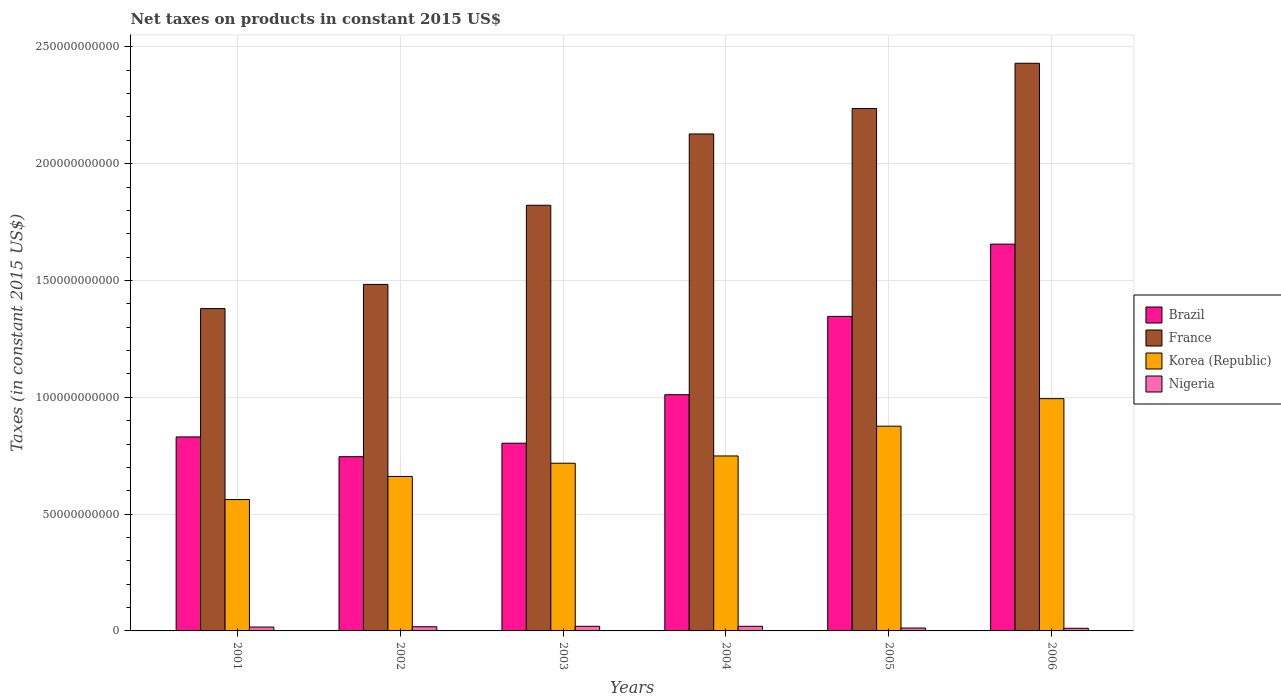How many groups of bars are there?
Provide a short and direct response. 6. Are the number of bars per tick equal to the number of legend labels?
Your response must be concise. Yes. Are the number of bars on each tick of the X-axis equal?
Your answer should be compact. Yes. How many bars are there on the 4th tick from the left?
Your answer should be compact. 4. How many bars are there on the 4th tick from the right?
Your answer should be compact. 4. What is the label of the 6th group of bars from the left?
Give a very brief answer. 2006. In how many cases, is the number of bars for a given year not equal to the number of legend labels?
Provide a succinct answer. 0. What is the net taxes on products in France in 2005?
Offer a very short reply. 2.24e+11. Across all years, what is the maximum net taxes on products in France?
Offer a terse response. 2.43e+11. Across all years, what is the minimum net taxes on products in France?
Keep it short and to the point. 1.38e+11. In which year was the net taxes on products in Korea (Republic) minimum?
Make the answer very short. 2001. What is the total net taxes on products in Nigeria in the graph?
Provide a succinct answer. 9.77e+09. What is the difference between the net taxes on products in Nigeria in 2002 and that in 2003?
Your answer should be compact. -1.88e+08. What is the difference between the net taxes on products in Nigeria in 2005 and the net taxes on products in Brazil in 2003?
Provide a succinct answer. -7.91e+1. What is the average net taxes on products in Korea (Republic) per year?
Make the answer very short. 7.60e+1. In the year 2005, what is the difference between the net taxes on products in Brazil and net taxes on products in Korea (Republic)?
Your answer should be very brief. 4.70e+1. What is the ratio of the net taxes on products in Brazil in 2002 to that in 2004?
Give a very brief answer. 0.74. Is the difference between the net taxes on products in Brazil in 2002 and 2005 greater than the difference between the net taxes on products in Korea (Republic) in 2002 and 2005?
Make the answer very short. No. What is the difference between the highest and the second highest net taxes on products in Brazil?
Ensure brevity in your answer.  3.09e+1. What is the difference between the highest and the lowest net taxes on products in Brazil?
Provide a succinct answer. 9.10e+1. What does the 2nd bar from the left in 2005 represents?
Give a very brief answer. France. What does the 2nd bar from the right in 2004 represents?
Your answer should be very brief. Korea (Republic). Is it the case that in every year, the sum of the net taxes on products in Nigeria and net taxes on products in Korea (Republic) is greater than the net taxes on products in France?
Your answer should be compact. No. Are all the bars in the graph horizontal?
Give a very brief answer. No. Does the graph contain any zero values?
Provide a short and direct response. No. Does the graph contain grids?
Give a very brief answer. Yes. Where does the legend appear in the graph?
Ensure brevity in your answer.  Center right. How many legend labels are there?
Keep it short and to the point. 4. What is the title of the graph?
Give a very brief answer. Net taxes on products in constant 2015 US$. What is the label or title of the Y-axis?
Your answer should be compact. Taxes (in constant 2015 US$). What is the Taxes (in constant 2015 US$) in Brazil in 2001?
Your answer should be very brief. 8.30e+1. What is the Taxes (in constant 2015 US$) in France in 2001?
Your answer should be very brief. 1.38e+11. What is the Taxes (in constant 2015 US$) in Korea (Republic) in 2001?
Ensure brevity in your answer.  5.62e+1. What is the Taxes (in constant 2015 US$) in Nigeria in 2001?
Ensure brevity in your answer.  1.66e+09. What is the Taxes (in constant 2015 US$) in Brazil in 2002?
Provide a succinct answer. 7.46e+1. What is the Taxes (in constant 2015 US$) in France in 2002?
Your answer should be very brief. 1.48e+11. What is the Taxes (in constant 2015 US$) of Korea (Republic) in 2002?
Offer a terse response. 6.61e+1. What is the Taxes (in constant 2015 US$) of Nigeria in 2002?
Keep it short and to the point. 1.79e+09. What is the Taxes (in constant 2015 US$) of Brazil in 2003?
Provide a succinct answer. 8.03e+1. What is the Taxes (in constant 2015 US$) of France in 2003?
Offer a very short reply. 1.82e+11. What is the Taxes (in constant 2015 US$) in Korea (Republic) in 2003?
Give a very brief answer. 7.18e+1. What is the Taxes (in constant 2015 US$) of Nigeria in 2003?
Give a very brief answer. 1.98e+09. What is the Taxes (in constant 2015 US$) of Brazil in 2004?
Provide a succinct answer. 1.01e+11. What is the Taxes (in constant 2015 US$) of France in 2004?
Keep it short and to the point. 2.13e+11. What is the Taxes (in constant 2015 US$) of Korea (Republic) in 2004?
Make the answer very short. 7.49e+1. What is the Taxes (in constant 2015 US$) in Nigeria in 2004?
Ensure brevity in your answer.  1.98e+09. What is the Taxes (in constant 2015 US$) of Brazil in 2005?
Provide a succinct answer. 1.35e+11. What is the Taxes (in constant 2015 US$) of France in 2005?
Offer a terse response. 2.24e+11. What is the Taxes (in constant 2015 US$) of Korea (Republic) in 2005?
Provide a succinct answer. 8.76e+1. What is the Taxes (in constant 2015 US$) of Nigeria in 2005?
Offer a terse response. 1.24e+09. What is the Taxes (in constant 2015 US$) of Brazil in 2006?
Keep it short and to the point. 1.66e+11. What is the Taxes (in constant 2015 US$) in France in 2006?
Ensure brevity in your answer.  2.43e+11. What is the Taxes (in constant 2015 US$) of Korea (Republic) in 2006?
Provide a short and direct response. 9.94e+1. What is the Taxes (in constant 2015 US$) in Nigeria in 2006?
Offer a very short reply. 1.13e+09. Across all years, what is the maximum Taxes (in constant 2015 US$) of Brazil?
Keep it short and to the point. 1.66e+11. Across all years, what is the maximum Taxes (in constant 2015 US$) in France?
Ensure brevity in your answer.  2.43e+11. Across all years, what is the maximum Taxes (in constant 2015 US$) in Korea (Republic)?
Make the answer very short. 9.94e+1. Across all years, what is the maximum Taxes (in constant 2015 US$) in Nigeria?
Keep it short and to the point. 1.98e+09. Across all years, what is the minimum Taxes (in constant 2015 US$) of Brazil?
Give a very brief answer. 7.46e+1. Across all years, what is the minimum Taxes (in constant 2015 US$) of France?
Make the answer very short. 1.38e+11. Across all years, what is the minimum Taxes (in constant 2015 US$) of Korea (Republic)?
Your answer should be very brief. 5.62e+1. Across all years, what is the minimum Taxes (in constant 2015 US$) of Nigeria?
Ensure brevity in your answer.  1.13e+09. What is the total Taxes (in constant 2015 US$) in Brazil in the graph?
Make the answer very short. 6.39e+11. What is the total Taxes (in constant 2015 US$) in France in the graph?
Provide a short and direct response. 1.15e+12. What is the total Taxes (in constant 2015 US$) in Korea (Republic) in the graph?
Provide a short and direct response. 4.56e+11. What is the total Taxes (in constant 2015 US$) of Nigeria in the graph?
Offer a very short reply. 9.77e+09. What is the difference between the Taxes (in constant 2015 US$) in Brazil in 2001 and that in 2002?
Your answer should be compact. 8.47e+09. What is the difference between the Taxes (in constant 2015 US$) in France in 2001 and that in 2002?
Ensure brevity in your answer.  -1.04e+1. What is the difference between the Taxes (in constant 2015 US$) of Korea (Republic) in 2001 and that in 2002?
Your response must be concise. -9.88e+09. What is the difference between the Taxes (in constant 2015 US$) of Nigeria in 2001 and that in 2002?
Your answer should be very brief. -1.32e+08. What is the difference between the Taxes (in constant 2015 US$) of Brazil in 2001 and that in 2003?
Make the answer very short. 2.69e+09. What is the difference between the Taxes (in constant 2015 US$) in France in 2001 and that in 2003?
Make the answer very short. -4.42e+1. What is the difference between the Taxes (in constant 2015 US$) of Korea (Republic) in 2001 and that in 2003?
Your response must be concise. -1.55e+1. What is the difference between the Taxes (in constant 2015 US$) of Nigeria in 2001 and that in 2003?
Your response must be concise. -3.20e+08. What is the difference between the Taxes (in constant 2015 US$) in Brazil in 2001 and that in 2004?
Provide a succinct answer. -1.81e+1. What is the difference between the Taxes (in constant 2015 US$) in France in 2001 and that in 2004?
Give a very brief answer. -7.48e+1. What is the difference between the Taxes (in constant 2015 US$) of Korea (Republic) in 2001 and that in 2004?
Keep it short and to the point. -1.87e+1. What is the difference between the Taxes (in constant 2015 US$) in Nigeria in 2001 and that in 2004?
Offer a terse response. -3.17e+08. What is the difference between the Taxes (in constant 2015 US$) of Brazil in 2001 and that in 2005?
Make the answer very short. -5.16e+1. What is the difference between the Taxes (in constant 2015 US$) in France in 2001 and that in 2005?
Make the answer very short. -8.57e+1. What is the difference between the Taxes (in constant 2015 US$) of Korea (Republic) in 2001 and that in 2005?
Offer a terse response. -3.14e+1. What is the difference between the Taxes (in constant 2015 US$) of Nigeria in 2001 and that in 2005?
Offer a terse response. 4.16e+08. What is the difference between the Taxes (in constant 2015 US$) in Brazil in 2001 and that in 2006?
Offer a terse response. -8.25e+1. What is the difference between the Taxes (in constant 2015 US$) of France in 2001 and that in 2006?
Offer a very short reply. -1.05e+11. What is the difference between the Taxes (in constant 2015 US$) of Korea (Republic) in 2001 and that in 2006?
Provide a short and direct response. -4.32e+1. What is the difference between the Taxes (in constant 2015 US$) of Nigeria in 2001 and that in 2006?
Make the answer very short. 5.31e+08. What is the difference between the Taxes (in constant 2015 US$) of Brazil in 2002 and that in 2003?
Offer a terse response. -5.77e+09. What is the difference between the Taxes (in constant 2015 US$) of France in 2002 and that in 2003?
Your answer should be very brief. -3.39e+1. What is the difference between the Taxes (in constant 2015 US$) of Korea (Republic) in 2002 and that in 2003?
Provide a succinct answer. -5.66e+09. What is the difference between the Taxes (in constant 2015 US$) of Nigeria in 2002 and that in 2003?
Offer a terse response. -1.88e+08. What is the difference between the Taxes (in constant 2015 US$) of Brazil in 2002 and that in 2004?
Your response must be concise. -2.65e+1. What is the difference between the Taxes (in constant 2015 US$) of France in 2002 and that in 2004?
Ensure brevity in your answer.  -6.44e+1. What is the difference between the Taxes (in constant 2015 US$) in Korea (Republic) in 2002 and that in 2004?
Provide a succinct answer. -8.77e+09. What is the difference between the Taxes (in constant 2015 US$) of Nigeria in 2002 and that in 2004?
Provide a short and direct response. -1.86e+08. What is the difference between the Taxes (in constant 2015 US$) in Brazil in 2002 and that in 2005?
Provide a short and direct response. -6.01e+1. What is the difference between the Taxes (in constant 2015 US$) of France in 2002 and that in 2005?
Give a very brief answer. -7.53e+1. What is the difference between the Taxes (in constant 2015 US$) of Korea (Republic) in 2002 and that in 2005?
Your answer should be very brief. -2.15e+1. What is the difference between the Taxes (in constant 2015 US$) in Nigeria in 2002 and that in 2005?
Your response must be concise. 5.48e+08. What is the difference between the Taxes (in constant 2015 US$) of Brazil in 2002 and that in 2006?
Provide a succinct answer. -9.10e+1. What is the difference between the Taxes (in constant 2015 US$) of France in 2002 and that in 2006?
Your answer should be very brief. -9.47e+1. What is the difference between the Taxes (in constant 2015 US$) of Korea (Republic) in 2002 and that in 2006?
Your response must be concise. -3.33e+1. What is the difference between the Taxes (in constant 2015 US$) of Nigeria in 2002 and that in 2006?
Make the answer very short. 6.63e+08. What is the difference between the Taxes (in constant 2015 US$) in Brazil in 2003 and that in 2004?
Give a very brief answer. -2.08e+1. What is the difference between the Taxes (in constant 2015 US$) of France in 2003 and that in 2004?
Make the answer very short. -3.05e+1. What is the difference between the Taxes (in constant 2015 US$) in Korea (Republic) in 2003 and that in 2004?
Provide a short and direct response. -3.11e+09. What is the difference between the Taxes (in constant 2015 US$) of Nigeria in 2003 and that in 2004?
Your answer should be very brief. 2.49e+06. What is the difference between the Taxes (in constant 2015 US$) of Brazil in 2003 and that in 2005?
Make the answer very short. -5.43e+1. What is the difference between the Taxes (in constant 2015 US$) of France in 2003 and that in 2005?
Ensure brevity in your answer.  -4.14e+1. What is the difference between the Taxes (in constant 2015 US$) in Korea (Republic) in 2003 and that in 2005?
Keep it short and to the point. -1.59e+1. What is the difference between the Taxes (in constant 2015 US$) of Nigeria in 2003 and that in 2005?
Give a very brief answer. 7.36e+08. What is the difference between the Taxes (in constant 2015 US$) of Brazil in 2003 and that in 2006?
Your answer should be very brief. -8.52e+1. What is the difference between the Taxes (in constant 2015 US$) in France in 2003 and that in 2006?
Offer a very short reply. -6.08e+1. What is the difference between the Taxes (in constant 2015 US$) of Korea (Republic) in 2003 and that in 2006?
Offer a very short reply. -2.76e+1. What is the difference between the Taxes (in constant 2015 US$) in Nigeria in 2003 and that in 2006?
Your response must be concise. 8.51e+08. What is the difference between the Taxes (in constant 2015 US$) in Brazil in 2004 and that in 2005?
Keep it short and to the point. -3.35e+1. What is the difference between the Taxes (in constant 2015 US$) in France in 2004 and that in 2005?
Provide a succinct answer. -1.09e+1. What is the difference between the Taxes (in constant 2015 US$) of Korea (Republic) in 2004 and that in 2005?
Your response must be concise. -1.27e+1. What is the difference between the Taxes (in constant 2015 US$) in Nigeria in 2004 and that in 2005?
Keep it short and to the point. 7.33e+08. What is the difference between the Taxes (in constant 2015 US$) in Brazil in 2004 and that in 2006?
Your response must be concise. -6.45e+1. What is the difference between the Taxes (in constant 2015 US$) in France in 2004 and that in 2006?
Offer a very short reply. -3.03e+1. What is the difference between the Taxes (in constant 2015 US$) in Korea (Republic) in 2004 and that in 2006?
Provide a succinct answer. -2.45e+1. What is the difference between the Taxes (in constant 2015 US$) in Nigeria in 2004 and that in 2006?
Your answer should be compact. 8.49e+08. What is the difference between the Taxes (in constant 2015 US$) in Brazil in 2005 and that in 2006?
Provide a succinct answer. -3.09e+1. What is the difference between the Taxes (in constant 2015 US$) in France in 2005 and that in 2006?
Provide a succinct answer. -1.94e+1. What is the difference between the Taxes (in constant 2015 US$) in Korea (Republic) in 2005 and that in 2006?
Your answer should be very brief. -1.18e+1. What is the difference between the Taxes (in constant 2015 US$) of Nigeria in 2005 and that in 2006?
Your answer should be compact. 1.15e+08. What is the difference between the Taxes (in constant 2015 US$) in Brazil in 2001 and the Taxes (in constant 2015 US$) in France in 2002?
Provide a succinct answer. -6.53e+1. What is the difference between the Taxes (in constant 2015 US$) in Brazil in 2001 and the Taxes (in constant 2015 US$) in Korea (Republic) in 2002?
Your answer should be very brief. 1.69e+1. What is the difference between the Taxes (in constant 2015 US$) in Brazil in 2001 and the Taxes (in constant 2015 US$) in Nigeria in 2002?
Your answer should be compact. 8.13e+1. What is the difference between the Taxes (in constant 2015 US$) of France in 2001 and the Taxes (in constant 2015 US$) of Korea (Republic) in 2002?
Provide a succinct answer. 7.19e+1. What is the difference between the Taxes (in constant 2015 US$) in France in 2001 and the Taxes (in constant 2015 US$) in Nigeria in 2002?
Your answer should be compact. 1.36e+11. What is the difference between the Taxes (in constant 2015 US$) in Korea (Republic) in 2001 and the Taxes (in constant 2015 US$) in Nigeria in 2002?
Provide a short and direct response. 5.44e+1. What is the difference between the Taxes (in constant 2015 US$) in Brazil in 2001 and the Taxes (in constant 2015 US$) in France in 2003?
Give a very brief answer. -9.92e+1. What is the difference between the Taxes (in constant 2015 US$) in Brazil in 2001 and the Taxes (in constant 2015 US$) in Korea (Republic) in 2003?
Offer a terse response. 1.13e+1. What is the difference between the Taxes (in constant 2015 US$) in Brazil in 2001 and the Taxes (in constant 2015 US$) in Nigeria in 2003?
Your response must be concise. 8.11e+1. What is the difference between the Taxes (in constant 2015 US$) of France in 2001 and the Taxes (in constant 2015 US$) of Korea (Republic) in 2003?
Provide a succinct answer. 6.62e+1. What is the difference between the Taxes (in constant 2015 US$) of France in 2001 and the Taxes (in constant 2015 US$) of Nigeria in 2003?
Your response must be concise. 1.36e+11. What is the difference between the Taxes (in constant 2015 US$) of Korea (Republic) in 2001 and the Taxes (in constant 2015 US$) of Nigeria in 2003?
Offer a terse response. 5.43e+1. What is the difference between the Taxes (in constant 2015 US$) in Brazil in 2001 and the Taxes (in constant 2015 US$) in France in 2004?
Your response must be concise. -1.30e+11. What is the difference between the Taxes (in constant 2015 US$) in Brazil in 2001 and the Taxes (in constant 2015 US$) in Korea (Republic) in 2004?
Provide a succinct answer. 8.15e+09. What is the difference between the Taxes (in constant 2015 US$) in Brazil in 2001 and the Taxes (in constant 2015 US$) in Nigeria in 2004?
Offer a terse response. 8.11e+1. What is the difference between the Taxes (in constant 2015 US$) of France in 2001 and the Taxes (in constant 2015 US$) of Korea (Republic) in 2004?
Give a very brief answer. 6.31e+1. What is the difference between the Taxes (in constant 2015 US$) in France in 2001 and the Taxes (in constant 2015 US$) in Nigeria in 2004?
Provide a succinct answer. 1.36e+11. What is the difference between the Taxes (in constant 2015 US$) of Korea (Republic) in 2001 and the Taxes (in constant 2015 US$) of Nigeria in 2004?
Make the answer very short. 5.43e+1. What is the difference between the Taxes (in constant 2015 US$) of Brazil in 2001 and the Taxes (in constant 2015 US$) of France in 2005?
Provide a succinct answer. -1.41e+11. What is the difference between the Taxes (in constant 2015 US$) in Brazil in 2001 and the Taxes (in constant 2015 US$) in Korea (Republic) in 2005?
Offer a very short reply. -4.60e+09. What is the difference between the Taxes (in constant 2015 US$) of Brazil in 2001 and the Taxes (in constant 2015 US$) of Nigeria in 2005?
Give a very brief answer. 8.18e+1. What is the difference between the Taxes (in constant 2015 US$) in France in 2001 and the Taxes (in constant 2015 US$) in Korea (Republic) in 2005?
Make the answer very short. 5.03e+1. What is the difference between the Taxes (in constant 2015 US$) in France in 2001 and the Taxes (in constant 2015 US$) in Nigeria in 2005?
Your answer should be compact. 1.37e+11. What is the difference between the Taxes (in constant 2015 US$) in Korea (Republic) in 2001 and the Taxes (in constant 2015 US$) in Nigeria in 2005?
Make the answer very short. 5.50e+1. What is the difference between the Taxes (in constant 2015 US$) of Brazil in 2001 and the Taxes (in constant 2015 US$) of France in 2006?
Your response must be concise. -1.60e+11. What is the difference between the Taxes (in constant 2015 US$) of Brazil in 2001 and the Taxes (in constant 2015 US$) of Korea (Republic) in 2006?
Your answer should be very brief. -1.64e+1. What is the difference between the Taxes (in constant 2015 US$) in Brazil in 2001 and the Taxes (in constant 2015 US$) in Nigeria in 2006?
Provide a succinct answer. 8.19e+1. What is the difference between the Taxes (in constant 2015 US$) in France in 2001 and the Taxes (in constant 2015 US$) in Korea (Republic) in 2006?
Offer a terse response. 3.85e+1. What is the difference between the Taxes (in constant 2015 US$) of France in 2001 and the Taxes (in constant 2015 US$) of Nigeria in 2006?
Make the answer very short. 1.37e+11. What is the difference between the Taxes (in constant 2015 US$) in Korea (Republic) in 2001 and the Taxes (in constant 2015 US$) in Nigeria in 2006?
Offer a terse response. 5.51e+1. What is the difference between the Taxes (in constant 2015 US$) of Brazil in 2002 and the Taxes (in constant 2015 US$) of France in 2003?
Provide a short and direct response. -1.08e+11. What is the difference between the Taxes (in constant 2015 US$) of Brazil in 2002 and the Taxes (in constant 2015 US$) of Korea (Republic) in 2003?
Offer a terse response. 2.80e+09. What is the difference between the Taxes (in constant 2015 US$) in Brazil in 2002 and the Taxes (in constant 2015 US$) in Nigeria in 2003?
Your answer should be very brief. 7.26e+1. What is the difference between the Taxes (in constant 2015 US$) in France in 2002 and the Taxes (in constant 2015 US$) in Korea (Republic) in 2003?
Provide a succinct answer. 7.65e+1. What is the difference between the Taxes (in constant 2015 US$) in France in 2002 and the Taxes (in constant 2015 US$) in Nigeria in 2003?
Make the answer very short. 1.46e+11. What is the difference between the Taxes (in constant 2015 US$) in Korea (Republic) in 2002 and the Taxes (in constant 2015 US$) in Nigeria in 2003?
Provide a succinct answer. 6.41e+1. What is the difference between the Taxes (in constant 2015 US$) in Brazil in 2002 and the Taxes (in constant 2015 US$) in France in 2004?
Provide a short and direct response. -1.38e+11. What is the difference between the Taxes (in constant 2015 US$) in Brazil in 2002 and the Taxes (in constant 2015 US$) in Korea (Republic) in 2004?
Give a very brief answer. -3.17e+08. What is the difference between the Taxes (in constant 2015 US$) of Brazil in 2002 and the Taxes (in constant 2015 US$) of Nigeria in 2004?
Ensure brevity in your answer.  7.26e+1. What is the difference between the Taxes (in constant 2015 US$) of France in 2002 and the Taxes (in constant 2015 US$) of Korea (Republic) in 2004?
Provide a succinct answer. 7.34e+1. What is the difference between the Taxes (in constant 2015 US$) in France in 2002 and the Taxes (in constant 2015 US$) in Nigeria in 2004?
Give a very brief answer. 1.46e+11. What is the difference between the Taxes (in constant 2015 US$) of Korea (Republic) in 2002 and the Taxes (in constant 2015 US$) of Nigeria in 2004?
Give a very brief answer. 6.41e+1. What is the difference between the Taxes (in constant 2015 US$) in Brazil in 2002 and the Taxes (in constant 2015 US$) in France in 2005?
Offer a terse response. -1.49e+11. What is the difference between the Taxes (in constant 2015 US$) of Brazil in 2002 and the Taxes (in constant 2015 US$) of Korea (Republic) in 2005?
Make the answer very short. -1.31e+1. What is the difference between the Taxes (in constant 2015 US$) of Brazil in 2002 and the Taxes (in constant 2015 US$) of Nigeria in 2005?
Your answer should be compact. 7.33e+1. What is the difference between the Taxes (in constant 2015 US$) of France in 2002 and the Taxes (in constant 2015 US$) of Korea (Republic) in 2005?
Offer a very short reply. 6.07e+1. What is the difference between the Taxes (in constant 2015 US$) in France in 2002 and the Taxes (in constant 2015 US$) in Nigeria in 2005?
Offer a very short reply. 1.47e+11. What is the difference between the Taxes (in constant 2015 US$) in Korea (Republic) in 2002 and the Taxes (in constant 2015 US$) in Nigeria in 2005?
Your response must be concise. 6.49e+1. What is the difference between the Taxes (in constant 2015 US$) of Brazil in 2002 and the Taxes (in constant 2015 US$) of France in 2006?
Give a very brief answer. -1.68e+11. What is the difference between the Taxes (in constant 2015 US$) of Brazil in 2002 and the Taxes (in constant 2015 US$) of Korea (Republic) in 2006?
Offer a terse response. -2.48e+1. What is the difference between the Taxes (in constant 2015 US$) of Brazil in 2002 and the Taxes (in constant 2015 US$) of Nigeria in 2006?
Your answer should be very brief. 7.34e+1. What is the difference between the Taxes (in constant 2015 US$) in France in 2002 and the Taxes (in constant 2015 US$) in Korea (Republic) in 2006?
Your response must be concise. 4.89e+1. What is the difference between the Taxes (in constant 2015 US$) of France in 2002 and the Taxes (in constant 2015 US$) of Nigeria in 2006?
Your answer should be compact. 1.47e+11. What is the difference between the Taxes (in constant 2015 US$) of Korea (Republic) in 2002 and the Taxes (in constant 2015 US$) of Nigeria in 2006?
Your answer should be very brief. 6.50e+1. What is the difference between the Taxes (in constant 2015 US$) of Brazil in 2003 and the Taxes (in constant 2015 US$) of France in 2004?
Your answer should be compact. -1.32e+11. What is the difference between the Taxes (in constant 2015 US$) in Brazil in 2003 and the Taxes (in constant 2015 US$) in Korea (Republic) in 2004?
Give a very brief answer. 5.46e+09. What is the difference between the Taxes (in constant 2015 US$) of Brazil in 2003 and the Taxes (in constant 2015 US$) of Nigeria in 2004?
Offer a very short reply. 7.84e+1. What is the difference between the Taxes (in constant 2015 US$) in France in 2003 and the Taxes (in constant 2015 US$) in Korea (Republic) in 2004?
Keep it short and to the point. 1.07e+11. What is the difference between the Taxes (in constant 2015 US$) in France in 2003 and the Taxes (in constant 2015 US$) in Nigeria in 2004?
Make the answer very short. 1.80e+11. What is the difference between the Taxes (in constant 2015 US$) in Korea (Republic) in 2003 and the Taxes (in constant 2015 US$) in Nigeria in 2004?
Provide a succinct answer. 6.98e+1. What is the difference between the Taxes (in constant 2015 US$) of Brazil in 2003 and the Taxes (in constant 2015 US$) of France in 2005?
Offer a terse response. -1.43e+11. What is the difference between the Taxes (in constant 2015 US$) in Brazil in 2003 and the Taxes (in constant 2015 US$) in Korea (Republic) in 2005?
Your answer should be compact. -7.29e+09. What is the difference between the Taxes (in constant 2015 US$) of Brazil in 2003 and the Taxes (in constant 2015 US$) of Nigeria in 2005?
Your answer should be compact. 7.91e+1. What is the difference between the Taxes (in constant 2015 US$) of France in 2003 and the Taxes (in constant 2015 US$) of Korea (Republic) in 2005?
Offer a very short reply. 9.46e+1. What is the difference between the Taxes (in constant 2015 US$) of France in 2003 and the Taxes (in constant 2015 US$) of Nigeria in 2005?
Provide a short and direct response. 1.81e+11. What is the difference between the Taxes (in constant 2015 US$) of Korea (Republic) in 2003 and the Taxes (in constant 2015 US$) of Nigeria in 2005?
Provide a short and direct response. 7.05e+1. What is the difference between the Taxes (in constant 2015 US$) of Brazil in 2003 and the Taxes (in constant 2015 US$) of France in 2006?
Provide a succinct answer. -1.63e+11. What is the difference between the Taxes (in constant 2015 US$) of Brazil in 2003 and the Taxes (in constant 2015 US$) of Korea (Republic) in 2006?
Give a very brief answer. -1.91e+1. What is the difference between the Taxes (in constant 2015 US$) in Brazil in 2003 and the Taxes (in constant 2015 US$) in Nigeria in 2006?
Provide a short and direct response. 7.92e+1. What is the difference between the Taxes (in constant 2015 US$) of France in 2003 and the Taxes (in constant 2015 US$) of Korea (Republic) in 2006?
Your answer should be compact. 8.28e+1. What is the difference between the Taxes (in constant 2015 US$) in France in 2003 and the Taxes (in constant 2015 US$) in Nigeria in 2006?
Give a very brief answer. 1.81e+11. What is the difference between the Taxes (in constant 2015 US$) of Korea (Republic) in 2003 and the Taxes (in constant 2015 US$) of Nigeria in 2006?
Keep it short and to the point. 7.07e+1. What is the difference between the Taxes (in constant 2015 US$) of Brazil in 2004 and the Taxes (in constant 2015 US$) of France in 2005?
Keep it short and to the point. -1.23e+11. What is the difference between the Taxes (in constant 2015 US$) in Brazil in 2004 and the Taxes (in constant 2015 US$) in Korea (Republic) in 2005?
Offer a very short reply. 1.35e+1. What is the difference between the Taxes (in constant 2015 US$) in Brazil in 2004 and the Taxes (in constant 2015 US$) in Nigeria in 2005?
Offer a terse response. 9.99e+1. What is the difference between the Taxes (in constant 2015 US$) in France in 2004 and the Taxes (in constant 2015 US$) in Korea (Republic) in 2005?
Offer a terse response. 1.25e+11. What is the difference between the Taxes (in constant 2015 US$) in France in 2004 and the Taxes (in constant 2015 US$) in Nigeria in 2005?
Ensure brevity in your answer.  2.11e+11. What is the difference between the Taxes (in constant 2015 US$) in Korea (Republic) in 2004 and the Taxes (in constant 2015 US$) in Nigeria in 2005?
Offer a terse response. 7.37e+1. What is the difference between the Taxes (in constant 2015 US$) of Brazil in 2004 and the Taxes (in constant 2015 US$) of France in 2006?
Your answer should be compact. -1.42e+11. What is the difference between the Taxes (in constant 2015 US$) of Brazil in 2004 and the Taxes (in constant 2015 US$) of Korea (Republic) in 2006?
Your answer should be compact. 1.70e+09. What is the difference between the Taxes (in constant 2015 US$) of Brazil in 2004 and the Taxes (in constant 2015 US$) of Nigeria in 2006?
Your answer should be compact. 1.00e+11. What is the difference between the Taxes (in constant 2015 US$) in France in 2004 and the Taxes (in constant 2015 US$) in Korea (Republic) in 2006?
Ensure brevity in your answer.  1.13e+11. What is the difference between the Taxes (in constant 2015 US$) in France in 2004 and the Taxes (in constant 2015 US$) in Nigeria in 2006?
Offer a very short reply. 2.12e+11. What is the difference between the Taxes (in constant 2015 US$) of Korea (Republic) in 2004 and the Taxes (in constant 2015 US$) of Nigeria in 2006?
Your answer should be very brief. 7.38e+1. What is the difference between the Taxes (in constant 2015 US$) of Brazil in 2005 and the Taxes (in constant 2015 US$) of France in 2006?
Ensure brevity in your answer.  -1.08e+11. What is the difference between the Taxes (in constant 2015 US$) in Brazil in 2005 and the Taxes (in constant 2015 US$) in Korea (Republic) in 2006?
Ensure brevity in your answer.  3.52e+1. What is the difference between the Taxes (in constant 2015 US$) of Brazil in 2005 and the Taxes (in constant 2015 US$) of Nigeria in 2006?
Provide a succinct answer. 1.34e+11. What is the difference between the Taxes (in constant 2015 US$) in France in 2005 and the Taxes (in constant 2015 US$) in Korea (Republic) in 2006?
Make the answer very short. 1.24e+11. What is the difference between the Taxes (in constant 2015 US$) in France in 2005 and the Taxes (in constant 2015 US$) in Nigeria in 2006?
Make the answer very short. 2.23e+11. What is the difference between the Taxes (in constant 2015 US$) in Korea (Republic) in 2005 and the Taxes (in constant 2015 US$) in Nigeria in 2006?
Ensure brevity in your answer.  8.65e+1. What is the average Taxes (in constant 2015 US$) in Brazil per year?
Offer a very short reply. 1.07e+11. What is the average Taxes (in constant 2015 US$) of France per year?
Your response must be concise. 1.91e+11. What is the average Taxes (in constant 2015 US$) of Korea (Republic) per year?
Make the answer very short. 7.60e+1. What is the average Taxes (in constant 2015 US$) in Nigeria per year?
Your answer should be very brief. 1.63e+09. In the year 2001, what is the difference between the Taxes (in constant 2015 US$) in Brazil and Taxes (in constant 2015 US$) in France?
Your answer should be very brief. -5.49e+1. In the year 2001, what is the difference between the Taxes (in constant 2015 US$) of Brazil and Taxes (in constant 2015 US$) of Korea (Republic)?
Offer a terse response. 2.68e+1. In the year 2001, what is the difference between the Taxes (in constant 2015 US$) in Brazil and Taxes (in constant 2015 US$) in Nigeria?
Keep it short and to the point. 8.14e+1. In the year 2001, what is the difference between the Taxes (in constant 2015 US$) in France and Taxes (in constant 2015 US$) in Korea (Republic)?
Provide a succinct answer. 8.17e+1. In the year 2001, what is the difference between the Taxes (in constant 2015 US$) in France and Taxes (in constant 2015 US$) in Nigeria?
Keep it short and to the point. 1.36e+11. In the year 2001, what is the difference between the Taxes (in constant 2015 US$) in Korea (Republic) and Taxes (in constant 2015 US$) in Nigeria?
Provide a short and direct response. 5.46e+1. In the year 2002, what is the difference between the Taxes (in constant 2015 US$) in Brazil and Taxes (in constant 2015 US$) in France?
Provide a short and direct response. -7.37e+1. In the year 2002, what is the difference between the Taxes (in constant 2015 US$) in Brazil and Taxes (in constant 2015 US$) in Korea (Republic)?
Provide a short and direct response. 8.45e+09. In the year 2002, what is the difference between the Taxes (in constant 2015 US$) in Brazil and Taxes (in constant 2015 US$) in Nigeria?
Offer a very short reply. 7.28e+1. In the year 2002, what is the difference between the Taxes (in constant 2015 US$) of France and Taxes (in constant 2015 US$) of Korea (Republic)?
Your answer should be very brief. 8.22e+1. In the year 2002, what is the difference between the Taxes (in constant 2015 US$) of France and Taxes (in constant 2015 US$) of Nigeria?
Provide a short and direct response. 1.47e+11. In the year 2002, what is the difference between the Taxes (in constant 2015 US$) in Korea (Republic) and Taxes (in constant 2015 US$) in Nigeria?
Provide a succinct answer. 6.43e+1. In the year 2003, what is the difference between the Taxes (in constant 2015 US$) in Brazil and Taxes (in constant 2015 US$) in France?
Your answer should be compact. -1.02e+11. In the year 2003, what is the difference between the Taxes (in constant 2015 US$) in Brazil and Taxes (in constant 2015 US$) in Korea (Republic)?
Give a very brief answer. 8.57e+09. In the year 2003, what is the difference between the Taxes (in constant 2015 US$) of Brazil and Taxes (in constant 2015 US$) of Nigeria?
Ensure brevity in your answer.  7.84e+1. In the year 2003, what is the difference between the Taxes (in constant 2015 US$) in France and Taxes (in constant 2015 US$) in Korea (Republic)?
Offer a very short reply. 1.10e+11. In the year 2003, what is the difference between the Taxes (in constant 2015 US$) of France and Taxes (in constant 2015 US$) of Nigeria?
Offer a terse response. 1.80e+11. In the year 2003, what is the difference between the Taxes (in constant 2015 US$) of Korea (Republic) and Taxes (in constant 2015 US$) of Nigeria?
Offer a very short reply. 6.98e+1. In the year 2004, what is the difference between the Taxes (in constant 2015 US$) in Brazil and Taxes (in constant 2015 US$) in France?
Your response must be concise. -1.12e+11. In the year 2004, what is the difference between the Taxes (in constant 2015 US$) of Brazil and Taxes (in constant 2015 US$) of Korea (Republic)?
Offer a terse response. 2.62e+1. In the year 2004, what is the difference between the Taxes (in constant 2015 US$) in Brazil and Taxes (in constant 2015 US$) in Nigeria?
Offer a terse response. 9.91e+1. In the year 2004, what is the difference between the Taxes (in constant 2015 US$) in France and Taxes (in constant 2015 US$) in Korea (Republic)?
Ensure brevity in your answer.  1.38e+11. In the year 2004, what is the difference between the Taxes (in constant 2015 US$) in France and Taxes (in constant 2015 US$) in Nigeria?
Provide a short and direct response. 2.11e+11. In the year 2004, what is the difference between the Taxes (in constant 2015 US$) of Korea (Republic) and Taxes (in constant 2015 US$) of Nigeria?
Your response must be concise. 7.29e+1. In the year 2005, what is the difference between the Taxes (in constant 2015 US$) in Brazil and Taxes (in constant 2015 US$) in France?
Your answer should be compact. -8.90e+1. In the year 2005, what is the difference between the Taxes (in constant 2015 US$) of Brazil and Taxes (in constant 2015 US$) of Korea (Republic)?
Ensure brevity in your answer.  4.70e+1. In the year 2005, what is the difference between the Taxes (in constant 2015 US$) of Brazil and Taxes (in constant 2015 US$) of Nigeria?
Keep it short and to the point. 1.33e+11. In the year 2005, what is the difference between the Taxes (in constant 2015 US$) of France and Taxes (in constant 2015 US$) of Korea (Republic)?
Your answer should be compact. 1.36e+11. In the year 2005, what is the difference between the Taxes (in constant 2015 US$) in France and Taxes (in constant 2015 US$) in Nigeria?
Your answer should be very brief. 2.22e+11. In the year 2005, what is the difference between the Taxes (in constant 2015 US$) in Korea (Republic) and Taxes (in constant 2015 US$) in Nigeria?
Keep it short and to the point. 8.64e+1. In the year 2006, what is the difference between the Taxes (in constant 2015 US$) of Brazil and Taxes (in constant 2015 US$) of France?
Make the answer very short. -7.74e+1. In the year 2006, what is the difference between the Taxes (in constant 2015 US$) in Brazil and Taxes (in constant 2015 US$) in Korea (Republic)?
Provide a short and direct response. 6.61e+1. In the year 2006, what is the difference between the Taxes (in constant 2015 US$) in Brazil and Taxes (in constant 2015 US$) in Nigeria?
Make the answer very short. 1.64e+11. In the year 2006, what is the difference between the Taxes (in constant 2015 US$) in France and Taxes (in constant 2015 US$) in Korea (Republic)?
Ensure brevity in your answer.  1.44e+11. In the year 2006, what is the difference between the Taxes (in constant 2015 US$) in France and Taxes (in constant 2015 US$) in Nigeria?
Your answer should be compact. 2.42e+11. In the year 2006, what is the difference between the Taxes (in constant 2015 US$) in Korea (Republic) and Taxes (in constant 2015 US$) in Nigeria?
Provide a succinct answer. 9.83e+1. What is the ratio of the Taxes (in constant 2015 US$) in Brazil in 2001 to that in 2002?
Ensure brevity in your answer.  1.11. What is the ratio of the Taxes (in constant 2015 US$) in France in 2001 to that in 2002?
Make the answer very short. 0.93. What is the ratio of the Taxes (in constant 2015 US$) of Korea (Republic) in 2001 to that in 2002?
Provide a succinct answer. 0.85. What is the ratio of the Taxes (in constant 2015 US$) of Nigeria in 2001 to that in 2002?
Give a very brief answer. 0.93. What is the ratio of the Taxes (in constant 2015 US$) in Brazil in 2001 to that in 2003?
Provide a succinct answer. 1.03. What is the ratio of the Taxes (in constant 2015 US$) in France in 2001 to that in 2003?
Offer a terse response. 0.76. What is the ratio of the Taxes (in constant 2015 US$) in Korea (Republic) in 2001 to that in 2003?
Make the answer very short. 0.78. What is the ratio of the Taxes (in constant 2015 US$) in Nigeria in 2001 to that in 2003?
Give a very brief answer. 0.84. What is the ratio of the Taxes (in constant 2015 US$) of Brazil in 2001 to that in 2004?
Your answer should be compact. 0.82. What is the ratio of the Taxes (in constant 2015 US$) in France in 2001 to that in 2004?
Keep it short and to the point. 0.65. What is the ratio of the Taxes (in constant 2015 US$) of Korea (Republic) in 2001 to that in 2004?
Keep it short and to the point. 0.75. What is the ratio of the Taxes (in constant 2015 US$) of Nigeria in 2001 to that in 2004?
Your answer should be very brief. 0.84. What is the ratio of the Taxes (in constant 2015 US$) in Brazil in 2001 to that in 2005?
Make the answer very short. 0.62. What is the ratio of the Taxes (in constant 2015 US$) in France in 2001 to that in 2005?
Ensure brevity in your answer.  0.62. What is the ratio of the Taxes (in constant 2015 US$) in Korea (Republic) in 2001 to that in 2005?
Offer a very short reply. 0.64. What is the ratio of the Taxes (in constant 2015 US$) of Nigeria in 2001 to that in 2005?
Make the answer very short. 1.33. What is the ratio of the Taxes (in constant 2015 US$) in Brazil in 2001 to that in 2006?
Provide a short and direct response. 0.5. What is the ratio of the Taxes (in constant 2015 US$) in France in 2001 to that in 2006?
Offer a very short reply. 0.57. What is the ratio of the Taxes (in constant 2015 US$) of Korea (Republic) in 2001 to that in 2006?
Give a very brief answer. 0.57. What is the ratio of the Taxes (in constant 2015 US$) of Nigeria in 2001 to that in 2006?
Ensure brevity in your answer.  1.47. What is the ratio of the Taxes (in constant 2015 US$) of Brazil in 2002 to that in 2003?
Your answer should be very brief. 0.93. What is the ratio of the Taxes (in constant 2015 US$) of France in 2002 to that in 2003?
Offer a very short reply. 0.81. What is the ratio of the Taxes (in constant 2015 US$) of Korea (Republic) in 2002 to that in 2003?
Offer a terse response. 0.92. What is the ratio of the Taxes (in constant 2015 US$) in Nigeria in 2002 to that in 2003?
Make the answer very short. 0.9. What is the ratio of the Taxes (in constant 2015 US$) in Brazil in 2002 to that in 2004?
Ensure brevity in your answer.  0.74. What is the ratio of the Taxes (in constant 2015 US$) in France in 2002 to that in 2004?
Provide a succinct answer. 0.7. What is the ratio of the Taxes (in constant 2015 US$) of Korea (Republic) in 2002 to that in 2004?
Ensure brevity in your answer.  0.88. What is the ratio of the Taxes (in constant 2015 US$) in Nigeria in 2002 to that in 2004?
Offer a very short reply. 0.91. What is the ratio of the Taxes (in constant 2015 US$) in Brazil in 2002 to that in 2005?
Make the answer very short. 0.55. What is the ratio of the Taxes (in constant 2015 US$) in France in 2002 to that in 2005?
Give a very brief answer. 0.66. What is the ratio of the Taxes (in constant 2015 US$) of Korea (Republic) in 2002 to that in 2005?
Offer a very short reply. 0.75. What is the ratio of the Taxes (in constant 2015 US$) in Nigeria in 2002 to that in 2005?
Provide a short and direct response. 1.44. What is the ratio of the Taxes (in constant 2015 US$) in Brazil in 2002 to that in 2006?
Your response must be concise. 0.45. What is the ratio of the Taxes (in constant 2015 US$) of France in 2002 to that in 2006?
Provide a succinct answer. 0.61. What is the ratio of the Taxes (in constant 2015 US$) of Korea (Republic) in 2002 to that in 2006?
Give a very brief answer. 0.67. What is the ratio of the Taxes (in constant 2015 US$) of Nigeria in 2002 to that in 2006?
Your answer should be compact. 1.59. What is the ratio of the Taxes (in constant 2015 US$) in Brazil in 2003 to that in 2004?
Your response must be concise. 0.79. What is the ratio of the Taxes (in constant 2015 US$) of France in 2003 to that in 2004?
Your answer should be compact. 0.86. What is the ratio of the Taxes (in constant 2015 US$) of Korea (Republic) in 2003 to that in 2004?
Your response must be concise. 0.96. What is the ratio of the Taxes (in constant 2015 US$) in Brazil in 2003 to that in 2005?
Keep it short and to the point. 0.6. What is the ratio of the Taxes (in constant 2015 US$) of France in 2003 to that in 2005?
Make the answer very short. 0.81. What is the ratio of the Taxes (in constant 2015 US$) of Korea (Republic) in 2003 to that in 2005?
Your answer should be compact. 0.82. What is the ratio of the Taxes (in constant 2015 US$) in Nigeria in 2003 to that in 2005?
Offer a very short reply. 1.59. What is the ratio of the Taxes (in constant 2015 US$) of Brazil in 2003 to that in 2006?
Ensure brevity in your answer.  0.49. What is the ratio of the Taxes (in constant 2015 US$) in France in 2003 to that in 2006?
Your answer should be very brief. 0.75. What is the ratio of the Taxes (in constant 2015 US$) of Korea (Republic) in 2003 to that in 2006?
Offer a very short reply. 0.72. What is the ratio of the Taxes (in constant 2015 US$) in Nigeria in 2003 to that in 2006?
Your response must be concise. 1.76. What is the ratio of the Taxes (in constant 2015 US$) in Brazil in 2004 to that in 2005?
Your response must be concise. 0.75. What is the ratio of the Taxes (in constant 2015 US$) in France in 2004 to that in 2005?
Offer a terse response. 0.95. What is the ratio of the Taxes (in constant 2015 US$) in Korea (Republic) in 2004 to that in 2005?
Offer a terse response. 0.85. What is the ratio of the Taxes (in constant 2015 US$) in Nigeria in 2004 to that in 2005?
Make the answer very short. 1.59. What is the ratio of the Taxes (in constant 2015 US$) in Brazil in 2004 to that in 2006?
Keep it short and to the point. 0.61. What is the ratio of the Taxes (in constant 2015 US$) of France in 2004 to that in 2006?
Your response must be concise. 0.88. What is the ratio of the Taxes (in constant 2015 US$) in Korea (Republic) in 2004 to that in 2006?
Offer a very short reply. 0.75. What is the ratio of the Taxes (in constant 2015 US$) of Nigeria in 2004 to that in 2006?
Keep it short and to the point. 1.75. What is the ratio of the Taxes (in constant 2015 US$) in Brazil in 2005 to that in 2006?
Provide a short and direct response. 0.81. What is the ratio of the Taxes (in constant 2015 US$) in France in 2005 to that in 2006?
Your answer should be very brief. 0.92. What is the ratio of the Taxes (in constant 2015 US$) in Korea (Republic) in 2005 to that in 2006?
Ensure brevity in your answer.  0.88. What is the ratio of the Taxes (in constant 2015 US$) in Nigeria in 2005 to that in 2006?
Offer a terse response. 1.1. What is the difference between the highest and the second highest Taxes (in constant 2015 US$) of Brazil?
Make the answer very short. 3.09e+1. What is the difference between the highest and the second highest Taxes (in constant 2015 US$) in France?
Ensure brevity in your answer.  1.94e+1. What is the difference between the highest and the second highest Taxes (in constant 2015 US$) in Korea (Republic)?
Your response must be concise. 1.18e+1. What is the difference between the highest and the second highest Taxes (in constant 2015 US$) in Nigeria?
Provide a short and direct response. 2.49e+06. What is the difference between the highest and the lowest Taxes (in constant 2015 US$) of Brazil?
Provide a short and direct response. 9.10e+1. What is the difference between the highest and the lowest Taxes (in constant 2015 US$) in France?
Keep it short and to the point. 1.05e+11. What is the difference between the highest and the lowest Taxes (in constant 2015 US$) of Korea (Republic)?
Your answer should be compact. 4.32e+1. What is the difference between the highest and the lowest Taxes (in constant 2015 US$) in Nigeria?
Offer a terse response. 8.51e+08. 